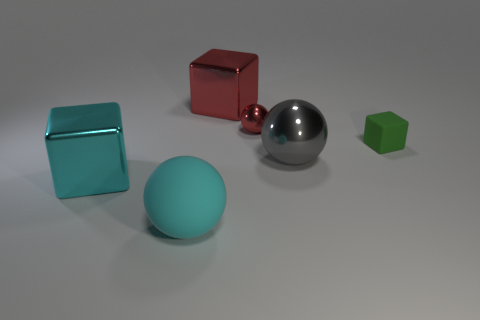Subtract all metallic cubes. How many cubes are left? 1 Add 2 small green matte things. How many objects exist? 8 Add 2 metallic objects. How many metallic objects are left? 6 Add 1 rubber balls. How many rubber balls exist? 2 Subtract 1 red blocks. How many objects are left? 5 Subtract all large brown matte things. Subtract all tiny red balls. How many objects are left? 5 